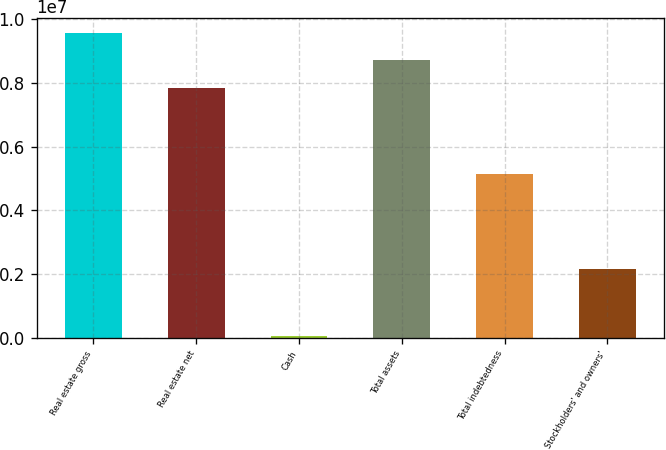Convert chart. <chart><loc_0><loc_0><loc_500><loc_500><bar_chart><fcel>Real estate gross<fcel>Real estate net<fcel>Cash<fcel>Total assets<fcel>Total indebtedness<fcel>Stockholders' and owners'<nl><fcel>9.57087e+06<fcel>7.84778e+06<fcel>55275<fcel>8.70932e+06<fcel>5.14722e+06<fcel>2.15959e+06<nl></chart> 